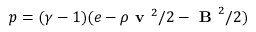<formula> <loc_0><loc_0><loc_500><loc_500>p = ( \gamma - 1 ) ( e - \rho v ^ { 2 } / 2 - B ^ { 2 } / 2 )</formula> 